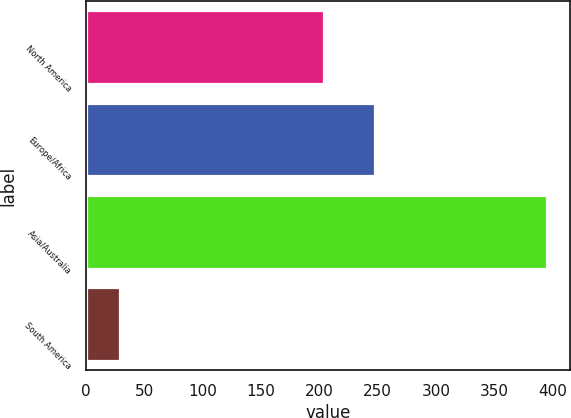Convert chart to OTSL. <chart><loc_0><loc_0><loc_500><loc_500><bar_chart><fcel>North America<fcel>Europe/Africa<fcel>Asia/Australia<fcel>South America<nl><fcel>204<fcel>248<fcel>395<fcel>29<nl></chart> 